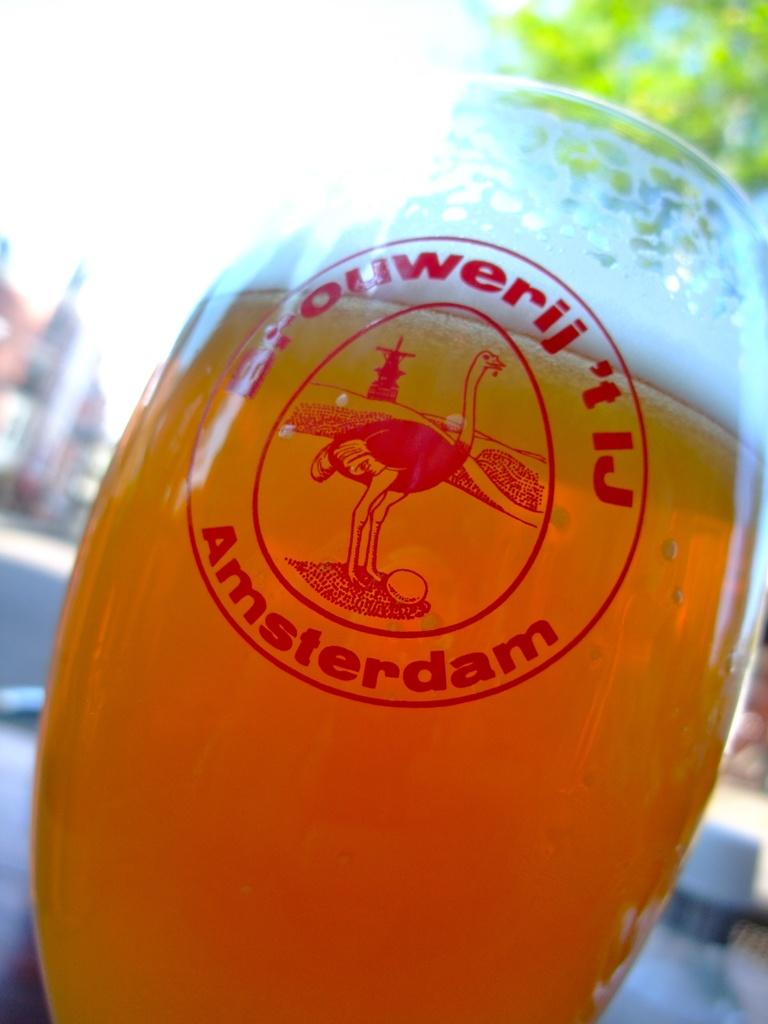What is in the wine glass that is visible in the image? The wine glass contains an orange-colored liquid. What can be seen in the background of the image? There is a road, buildings, the sky, and a tree visible in the background of the image. What type of wool is being spun by the leg in the image? There is no wool or leg present in the image. Is there a volcano visible in the background of the image? No, there is no volcano visible in the image; only a road, buildings, the sky, and a tree are present in the background. 